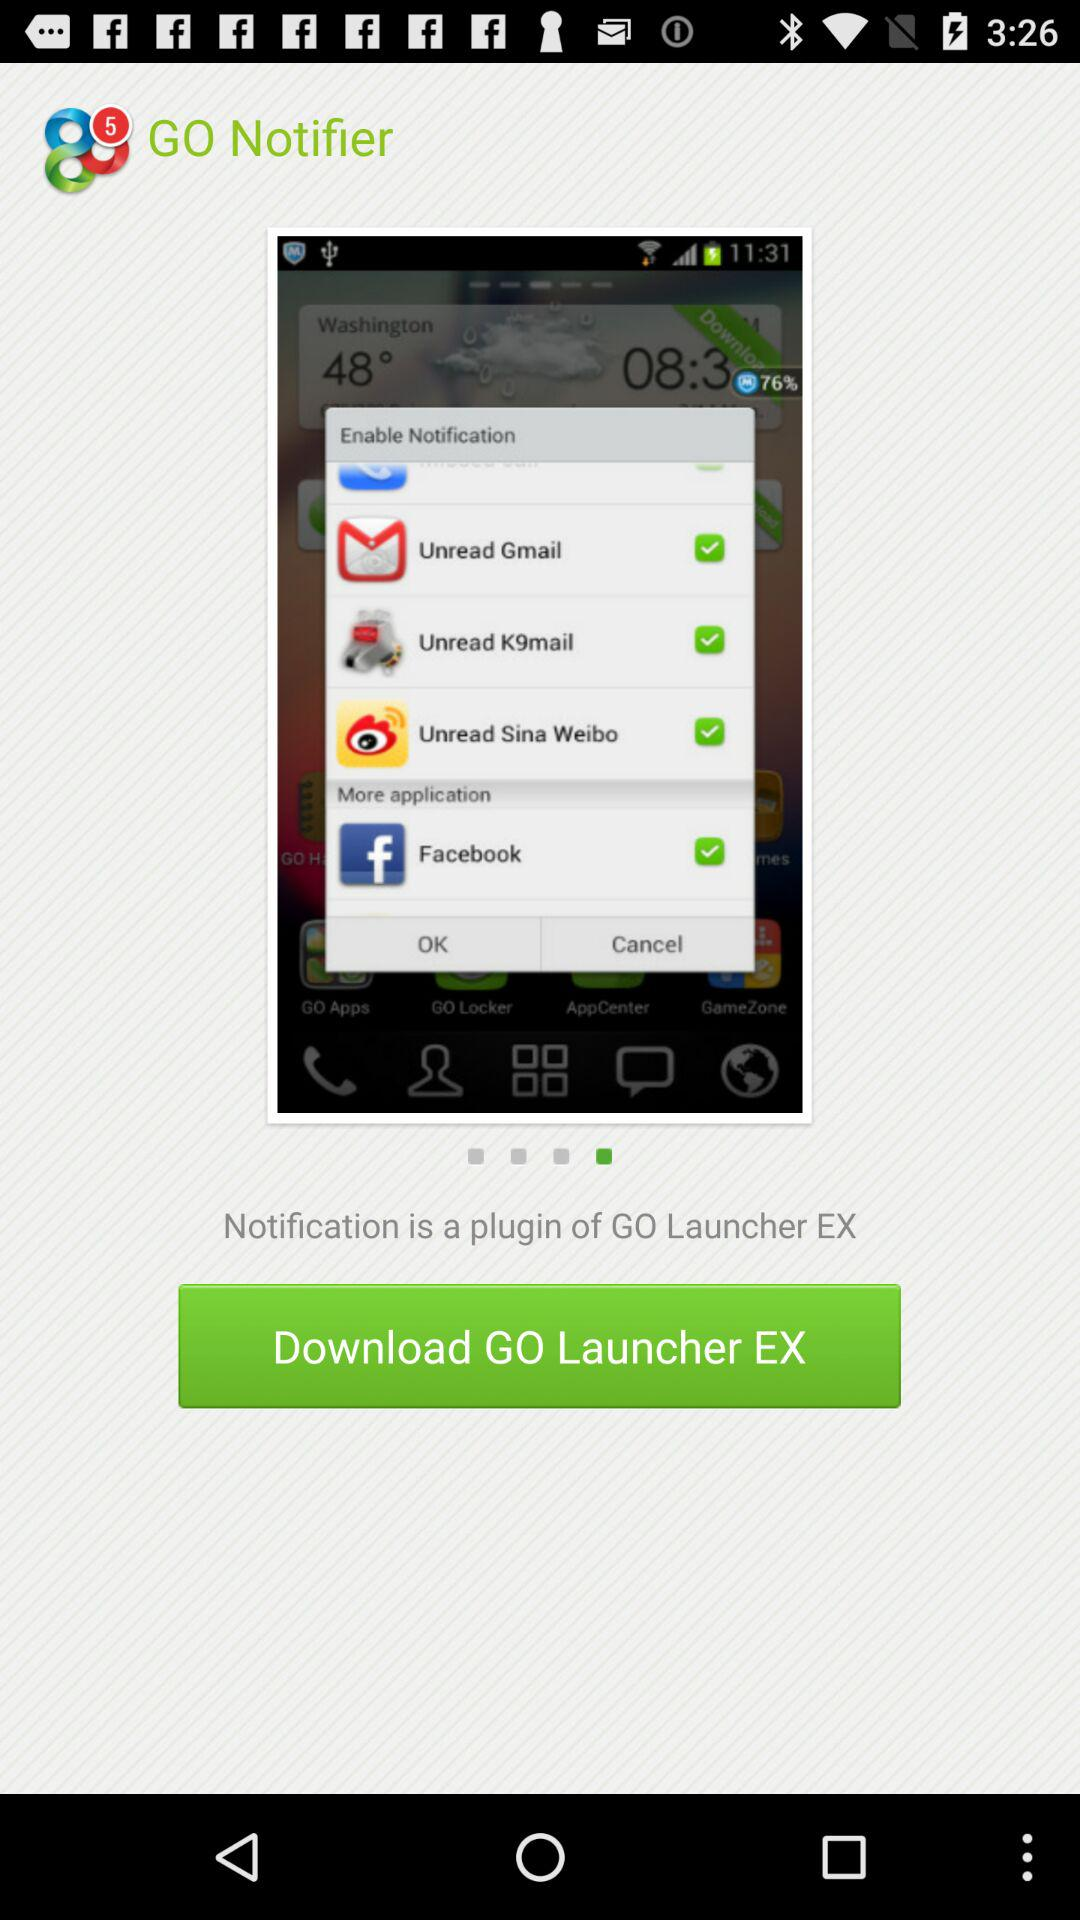What is the name of the application? The names of the applications are "GO Notifier" and "GO Launcher EX". 